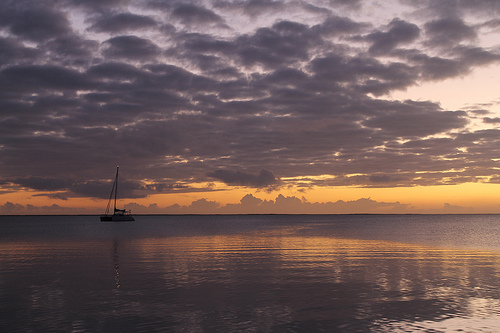<image>
Can you confirm if the boat is in the clouds? No. The boat is not contained within the clouds. These objects have a different spatial relationship. 